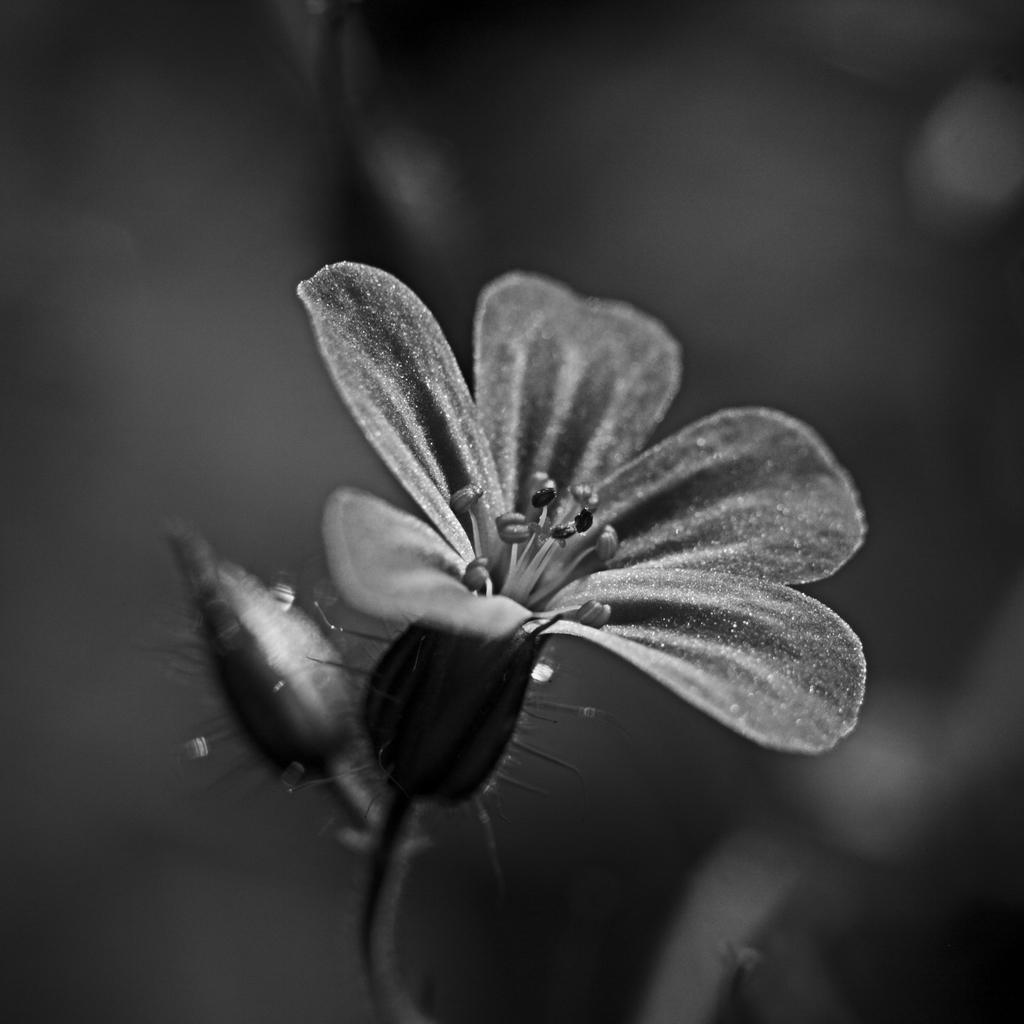What is the main subject in the middle of the image? There is a flower in the middle of the image. Can you describe the flower's stage of growth? The flower appears to be fully bloomed. What is located beside the flower? There is a bud beside the flower. What might happen to the bud in the future? The bud might bloom into a flower like the one beside it. What type of degree does the cub have in the image? There is there a cub present in the image? 